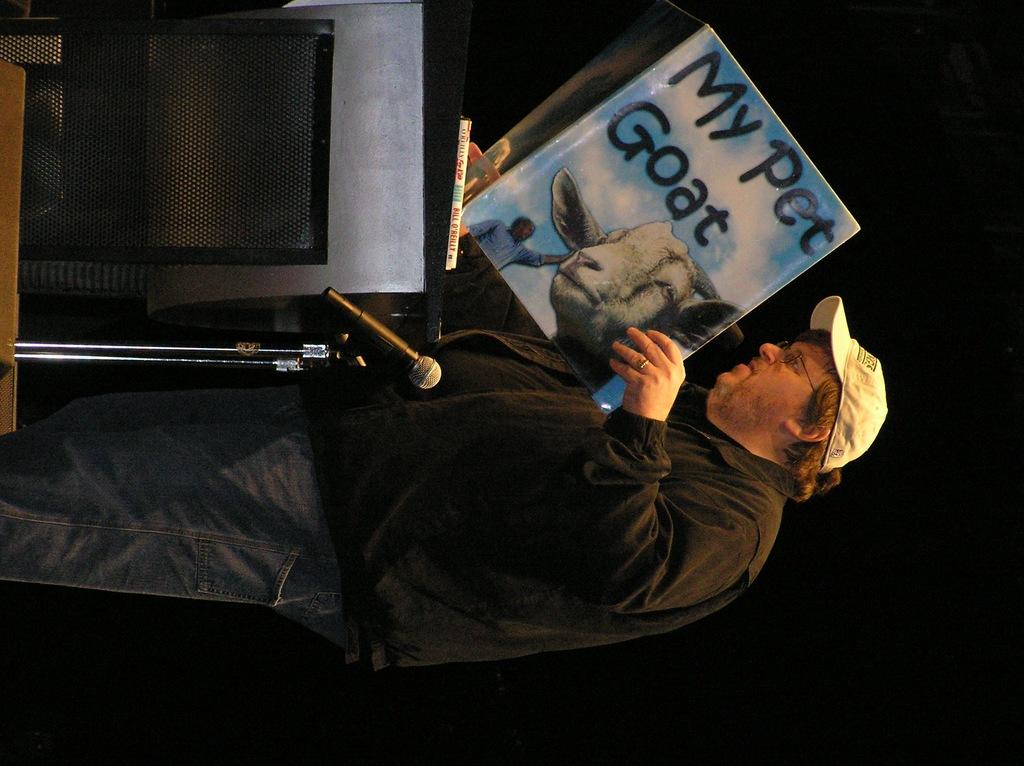Is that a story book?
Offer a very short reply. Yes. What book is that?
Ensure brevity in your answer.  My pet goat. 